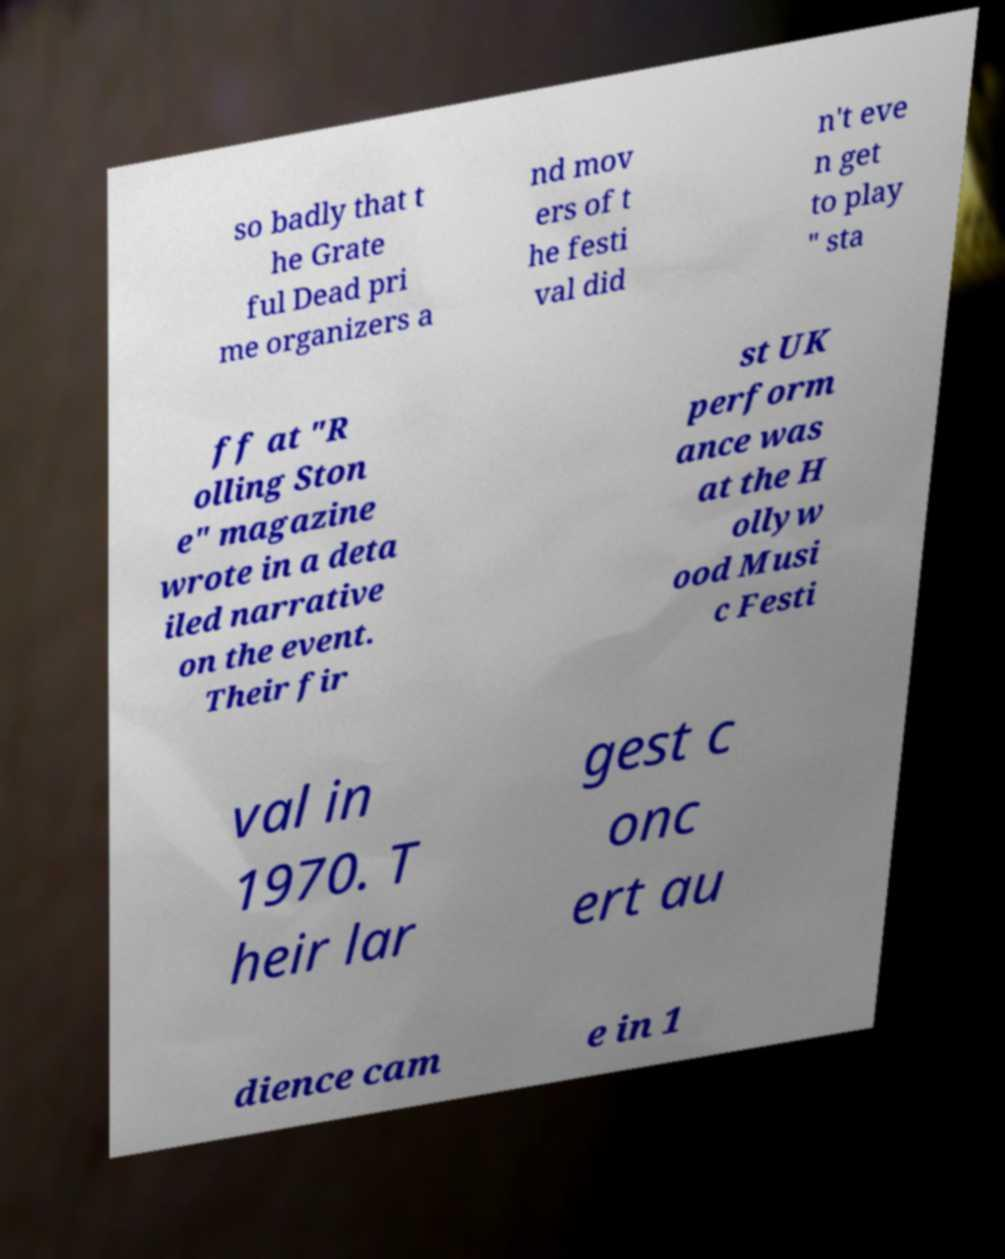For documentation purposes, I need the text within this image transcribed. Could you provide that? so badly that t he Grate ful Dead pri me organizers a nd mov ers of t he festi val did n't eve n get to play " sta ff at "R olling Ston e" magazine wrote in a deta iled narrative on the event. Their fir st UK perform ance was at the H ollyw ood Musi c Festi val in 1970. T heir lar gest c onc ert au dience cam e in 1 